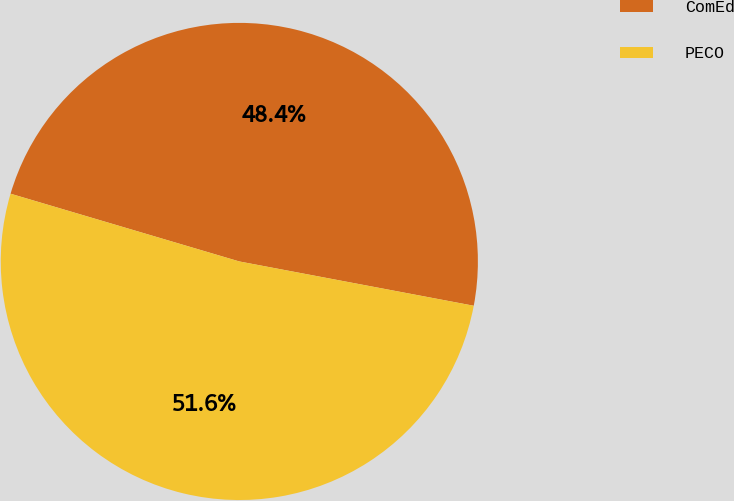Convert chart. <chart><loc_0><loc_0><loc_500><loc_500><pie_chart><fcel>ComEd<fcel>PECO<nl><fcel>48.39%<fcel>51.61%<nl></chart> 